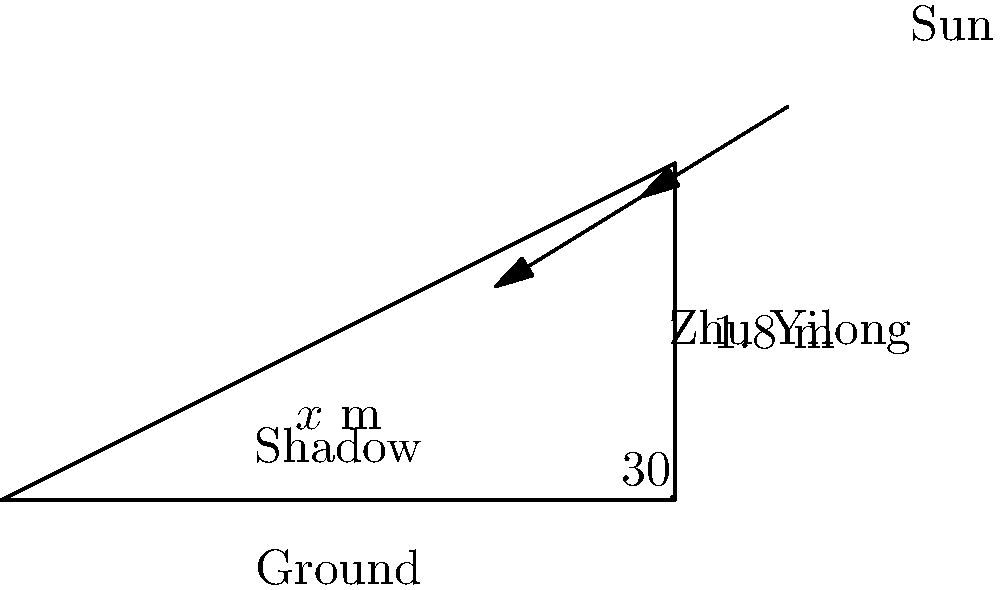Zhu Yilong, the beloved actor, is standing outside on a sunny day. If he is $1.8$ meters tall and the angle of elevation of the sun is $30°$, how long is his shadow on the ground? Round your answer to the nearest centimeter. Let's approach this step-by-step:

1) We can use the tangent function to solve this problem. The tangent of an angle in a right triangle is the ratio of the opposite side to the adjacent side.

2) In this case:
   - The angle is $30°$
   - The opposite side is Zhu Yilong's height (1.8 m)
   - The adjacent side is the length of the shadow (let's call it $x$)

3) We can write the equation:

   $$\tan(30°) = \frac{1.8}{x}$$

4) We know that $\tan(30°) = \frac{1}{\sqrt{3}}$, so we can rewrite the equation:

   $$\frac{1}{\sqrt{3}} = \frac{1.8}{x}$$

5) Cross multiply:

   $$x = 1.8 \sqrt{3}$$

6) Calculate the value:

   $$x \approx 3.1177 \text{ m}$$

7) Rounding to the nearest centimeter:

   $$x \approx 3.12 \text{ m}$$

Therefore, Zhu Yilong's shadow is approximately 3.12 meters long.
Answer: $3.12$ m 